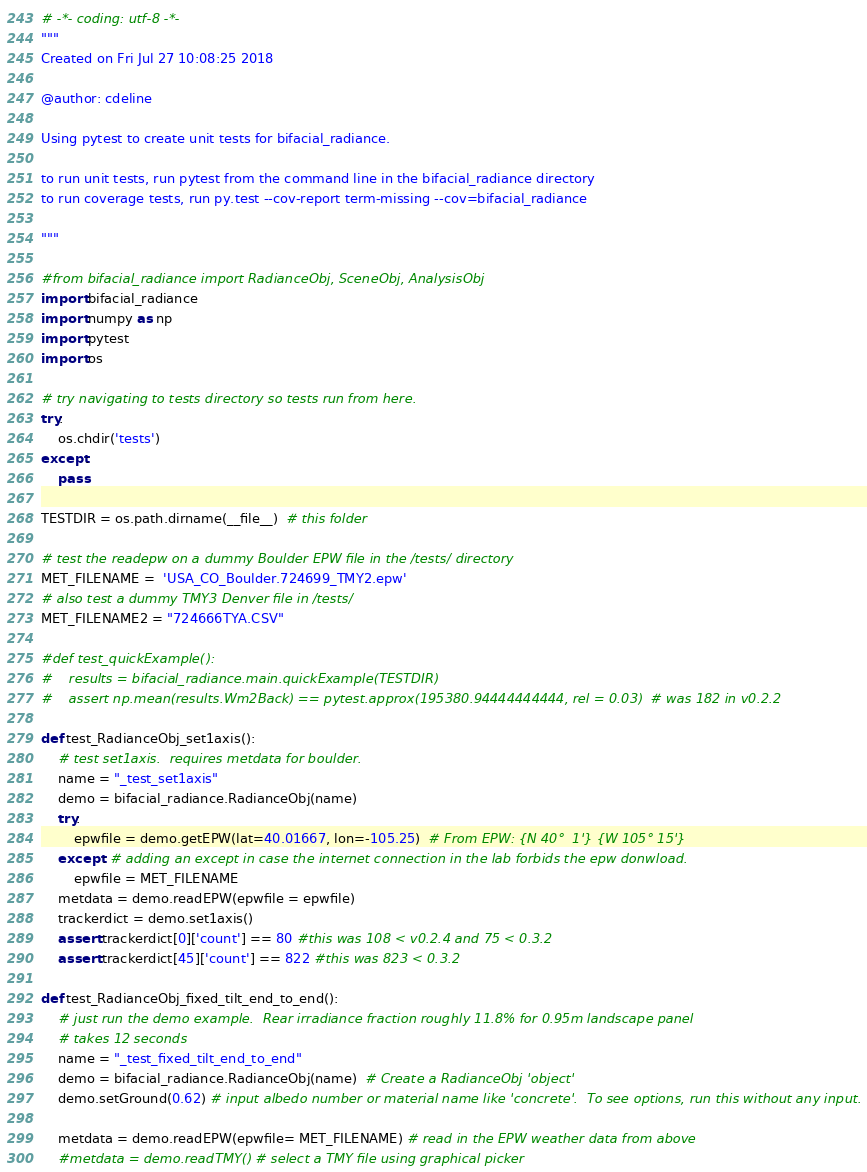<code> <loc_0><loc_0><loc_500><loc_500><_Python_># -*- coding: utf-8 -*-
"""
Created on Fri Jul 27 10:08:25 2018

@author: cdeline

Using pytest to create unit tests for bifacial_radiance.

to run unit tests, run pytest from the command line in the bifacial_radiance directory
to run coverage tests, run py.test --cov-report term-missing --cov=bifacial_radiance

"""

#from bifacial_radiance import RadianceObj, SceneObj, AnalysisObj
import bifacial_radiance
import numpy as np
import pytest
import os

# try navigating to tests directory so tests run from here.
try:
    os.chdir('tests')
except:
    pass

TESTDIR = os.path.dirname(__file__)  # this folder

# test the readepw on a dummy Boulder EPW file in the /tests/ directory
MET_FILENAME =  'USA_CO_Boulder.724699_TMY2.epw'
# also test a dummy TMY3 Denver file in /tests/
MET_FILENAME2 = "724666TYA.CSV"

#def test_quickExample():
#    results = bifacial_radiance.main.quickExample(TESTDIR)
#    assert np.mean(results.Wm2Back) == pytest.approx(195380.94444444444, rel = 0.03)  # was 182 in v0.2.2

def test_RadianceObj_set1axis():  
    # test set1axis.  requires metdata for boulder. 
    name = "_test_set1axis"
    demo = bifacial_radiance.RadianceObj(name)
    try:
        epwfile = demo.getEPW(lat=40.01667, lon=-105.25)  # From EPW: {N 40°  1'} {W 105° 15'}
    except: # adding an except in case the internet connection in the lab forbids the epw donwload.
        epwfile = MET_FILENAME
    metdata = demo.readEPW(epwfile = epwfile)
    trackerdict = demo.set1axis()
    assert trackerdict[0]['count'] == 80 #this was 108 < v0.2.4 and 75 < 0.3.2
    assert trackerdict[45]['count'] == 822 #this was 823 < 0.3.2
   
def test_RadianceObj_fixed_tilt_end_to_end():
    # just run the demo example.  Rear irradiance fraction roughly 11.8% for 0.95m landscape panel
    # takes 12 seconds
    name = "_test_fixed_tilt_end_to_end"
    demo = bifacial_radiance.RadianceObj(name)  # Create a RadianceObj 'object'
    demo.setGround(0.62) # input albedo number or material name like 'concrete'.  To see options, run this without any input.
  
    metdata = demo.readEPW(epwfile= MET_FILENAME) # read in the EPW weather data from above
    #metdata = demo.readTMY() # select a TMY file using graphical picker</code> 